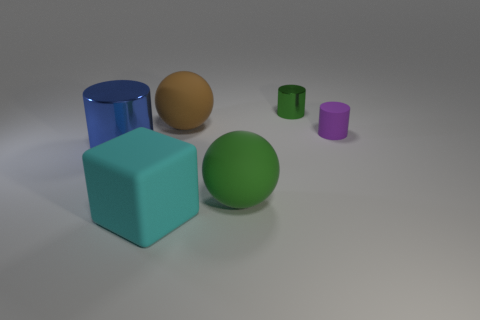Is the color of the big block the same as the big metal thing?
Make the answer very short. No. How many other objects are there of the same material as the purple cylinder?
Give a very brief answer. 3. What is the shape of the big thing that is behind the small cylinder on the right side of the green cylinder?
Offer a very short reply. Sphere. There is a shiny cylinder that is in front of the small purple thing; how big is it?
Provide a short and direct response. Large. Is the brown ball made of the same material as the big cylinder?
Your answer should be compact. No. There is a green object that is the same material as the big blue cylinder; what is its shape?
Provide a succinct answer. Cylinder. Is there anything else that is the same color as the small metallic cylinder?
Keep it short and to the point. Yes. What color is the matte object that is behind the tiny purple cylinder?
Offer a terse response. Brown. There is a big ball that is in front of the blue thing; does it have the same color as the large metallic object?
Provide a succinct answer. No. There is a blue object that is the same shape as the tiny purple thing; what material is it?
Your answer should be compact. Metal. 